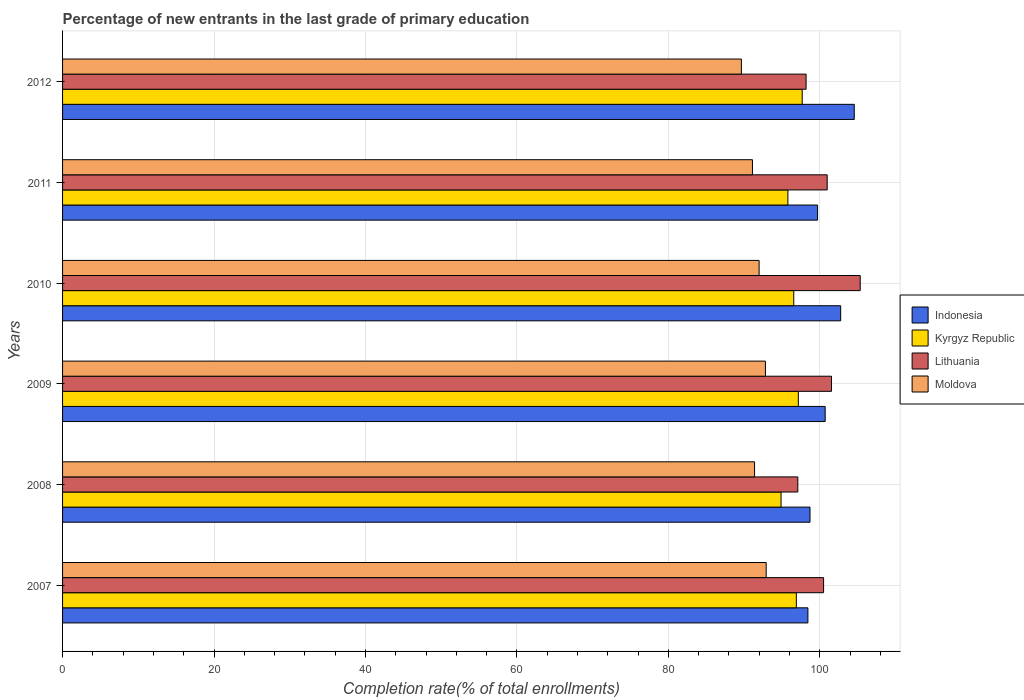Are the number of bars on each tick of the Y-axis equal?
Keep it short and to the point. Yes. How many bars are there on the 5th tick from the top?
Your answer should be very brief. 4. In how many cases, is the number of bars for a given year not equal to the number of legend labels?
Offer a very short reply. 0. What is the percentage of new entrants in Indonesia in 2010?
Offer a terse response. 102.75. Across all years, what is the maximum percentage of new entrants in Moldova?
Your answer should be very brief. 92.91. Across all years, what is the minimum percentage of new entrants in Indonesia?
Give a very brief answer. 98.42. In which year was the percentage of new entrants in Lithuania maximum?
Give a very brief answer. 2010. What is the total percentage of new entrants in Kyrgyz Republic in the graph?
Your answer should be compact. 578.94. What is the difference between the percentage of new entrants in Indonesia in 2007 and that in 2008?
Offer a very short reply. -0.28. What is the difference between the percentage of new entrants in Indonesia in 2008 and the percentage of new entrants in Moldova in 2007?
Make the answer very short. 5.79. What is the average percentage of new entrants in Lithuania per year?
Offer a terse response. 100.6. In the year 2007, what is the difference between the percentage of new entrants in Kyrgyz Republic and percentage of new entrants in Indonesia?
Provide a succinct answer. -1.53. What is the ratio of the percentage of new entrants in Kyrgyz Republic in 2007 to that in 2008?
Your answer should be compact. 1.02. Is the percentage of new entrants in Indonesia in 2009 less than that in 2011?
Make the answer very short. No. What is the difference between the highest and the second highest percentage of new entrants in Moldova?
Offer a terse response. 0.1. What is the difference between the highest and the lowest percentage of new entrants in Indonesia?
Your answer should be very brief. 6.12. In how many years, is the percentage of new entrants in Indonesia greater than the average percentage of new entrants in Indonesia taken over all years?
Ensure brevity in your answer.  2. Is it the case that in every year, the sum of the percentage of new entrants in Lithuania and percentage of new entrants in Kyrgyz Republic is greater than the sum of percentage of new entrants in Moldova and percentage of new entrants in Indonesia?
Your answer should be very brief. No. What does the 1st bar from the top in 2007 represents?
Offer a terse response. Moldova. Is it the case that in every year, the sum of the percentage of new entrants in Moldova and percentage of new entrants in Lithuania is greater than the percentage of new entrants in Kyrgyz Republic?
Give a very brief answer. Yes. How many bars are there?
Offer a very short reply. 24. What is the difference between two consecutive major ticks on the X-axis?
Your answer should be very brief. 20. Are the values on the major ticks of X-axis written in scientific E-notation?
Offer a terse response. No. Does the graph contain grids?
Give a very brief answer. Yes. Where does the legend appear in the graph?
Offer a very short reply. Center right. How are the legend labels stacked?
Give a very brief answer. Vertical. What is the title of the graph?
Provide a succinct answer. Percentage of new entrants in the last grade of primary education. Does "Togo" appear as one of the legend labels in the graph?
Provide a succinct answer. No. What is the label or title of the X-axis?
Make the answer very short. Completion rate(% of total enrollments). What is the Completion rate(% of total enrollments) of Indonesia in 2007?
Make the answer very short. 98.42. What is the Completion rate(% of total enrollments) in Kyrgyz Republic in 2007?
Make the answer very short. 96.9. What is the Completion rate(% of total enrollments) of Lithuania in 2007?
Provide a short and direct response. 100.5. What is the Completion rate(% of total enrollments) of Moldova in 2007?
Your answer should be compact. 92.91. What is the Completion rate(% of total enrollments) in Indonesia in 2008?
Make the answer very short. 98.7. What is the Completion rate(% of total enrollments) in Kyrgyz Republic in 2008?
Provide a succinct answer. 94.88. What is the Completion rate(% of total enrollments) in Lithuania in 2008?
Your answer should be compact. 97.09. What is the Completion rate(% of total enrollments) of Moldova in 2008?
Ensure brevity in your answer.  91.38. What is the Completion rate(% of total enrollments) in Indonesia in 2009?
Offer a very short reply. 100.7. What is the Completion rate(% of total enrollments) in Kyrgyz Republic in 2009?
Your answer should be very brief. 97.16. What is the Completion rate(% of total enrollments) in Lithuania in 2009?
Your answer should be very brief. 101.54. What is the Completion rate(% of total enrollments) of Moldova in 2009?
Provide a short and direct response. 92.82. What is the Completion rate(% of total enrollments) of Indonesia in 2010?
Provide a short and direct response. 102.75. What is the Completion rate(% of total enrollments) of Kyrgyz Republic in 2010?
Give a very brief answer. 96.56. What is the Completion rate(% of total enrollments) in Lithuania in 2010?
Provide a succinct answer. 105.33. What is the Completion rate(% of total enrollments) of Moldova in 2010?
Ensure brevity in your answer.  91.98. What is the Completion rate(% of total enrollments) in Indonesia in 2011?
Your response must be concise. 99.7. What is the Completion rate(% of total enrollments) of Kyrgyz Republic in 2011?
Your answer should be compact. 95.78. What is the Completion rate(% of total enrollments) in Lithuania in 2011?
Your answer should be very brief. 100.97. What is the Completion rate(% of total enrollments) of Moldova in 2011?
Make the answer very short. 91.1. What is the Completion rate(% of total enrollments) of Indonesia in 2012?
Provide a succinct answer. 104.54. What is the Completion rate(% of total enrollments) in Kyrgyz Republic in 2012?
Provide a succinct answer. 97.67. What is the Completion rate(% of total enrollments) in Lithuania in 2012?
Provide a succinct answer. 98.18. What is the Completion rate(% of total enrollments) of Moldova in 2012?
Offer a very short reply. 89.64. Across all years, what is the maximum Completion rate(% of total enrollments) of Indonesia?
Offer a very short reply. 104.54. Across all years, what is the maximum Completion rate(% of total enrollments) of Kyrgyz Republic?
Your response must be concise. 97.67. Across all years, what is the maximum Completion rate(% of total enrollments) of Lithuania?
Your response must be concise. 105.33. Across all years, what is the maximum Completion rate(% of total enrollments) of Moldova?
Provide a succinct answer. 92.91. Across all years, what is the minimum Completion rate(% of total enrollments) in Indonesia?
Make the answer very short. 98.42. Across all years, what is the minimum Completion rate(% of total enrollments) in Kyrgyz Republic?
Make the answer very short. 94.88. Across all years, what is the minimum Completion rate(% of total enrollments) of Lithuania?
Offer a very short reply. 97.09. Across all years, what is the minimum Completion rate(% of total enrollments) of Moldova?
Make the answer very short. 89.64. What is the total Completion rate(% of total enrollments) in Indonesia in the graph?
Offer a terse response. 604.82. What is the total Completion rate(% of total enrollments) in Kyrgyz Republic in the graph?
Offer a terse response. 578.94. What is the total Completion rate(% of total enrollments) in Lithuania in the graph?
Offer a terse response. 603.61. What is the total Completion rate(% of total enrollments) in Moldova in the graph?
Provide a succinct answer. 549.82. What is the difference between the Completion rate(% of total enrollments) in Indonesia in 2007 and that in 2008?
Ensure brevity in your answer.  -0.28. What is the difference between the Completion rate(% of total enrollments) of Kyrgyz Republic in 2007 and that in 2008?
Offer a terse response. 2.02. What is the difference between the Completion rate(% of total enrollments) of Lithuania in 2007 and that in 2008?
Your response must be concise. 3.4. What is the difference between the Completion rate(% of total enrollments) of Moldova in 2007 and that in 2008?
Make the answer very short. 1.54. What is the difference between the Completion rate(% of total enrollments) in Indonesia in 2007 and that in 2009?
Offer a very short reply. -2.28. What is the difference between the Completion rate(% of total enrollments) in Kyrgyz Republic in 2007 and that in 2009?
Provide a short and direct response. -0.26. What is the difference between the Completion rate(% of total enrollments) of Lithuania in 2007 and that in 2009?
Your response must be concise. -1.04. What is the difference between the Completion rate(% of total enrollments) of Moldova in 2007 and that in 2009?
Offer a very short reply. 0.1. What is the difference between the Completion rate(% of total enrollments) in Indonesia in 2007 and that in 2010?
Ensure brevity in your answer.  -4.33. What is the difference between the Completion rate(% of total enrollments) of Kyrgyz Republic in 2007 and that in 2010?
Make the answer very short. 0.34. What is the difference between the Completion rate(% of total enrollments) in Lithuania in 2007 and that in 2010?
Provide a short and direct response. -4.84. What is the difference between the Completion rate(% of total enrollments) in Moldova in 2007 and that in 2010?
Give a very brief answer. 0.93. What is the difference between the Completion rate(% of total enrollments) in Indonesia in 2007 and that in 2011?
Offer a very short reply. -1.28. What is the difference between the Completion rate(% of total enrollments) of Kyrgyz Republic in 2007 and that in 2011?
Give a very brief answer. 1.11. What is the difference between the Completion rate(% of total enrollments) in Lithuania in 2007 and that in 2011?
Make the answer very short. -0.47. What is the difference between the Completion rate(% of total enrollments) in Moldova in 2007 and that in 2011?
Offer a very short reply. 1.81. What is the difference between the Completion rate(% of total enrollments) in Indonesia in 2007 and that in 2012?
Offer a very short reply. -6.12. What is the difference between the Completion rate(% of total enrollments) in Kyrgyz Republic in 2007 and that in 2012?
Your answer should be very brief. -0.77. What is the difference between the Completion rate(% of total enrollments) in Lithuania in 2007 and that in 2012?
Make the answer very short. 2.31. What is the difference between the Completion rate(% of total enrollments) in Moldova in 2007 and that in 2012?
Make the answer very short. 3.27. What is the difference between the Completion rate(% of total enrollments) in Indonesia in 2008 and that in 2009?
Your answer should be very brief. -2. What is the difference between the Completion rate(% of total enrollments) in Kyrgyz Republic in 2008 and that in 2009?
Provide a succinct answer. -2.28. What is the difference between the Completion rate(% of total enrollments) in Lithuania in 2008 and that in 2009?
Give a very brief answer. -4.45. What is the difference between the Completion rate(% of total enrollments) in Moldova in 2008 and that in 2009?
Your answer should be compact. -1.44. What is the difference between the Completion rate(% of total enrollments) in Indonesia in 2008 and that in 2010?
Ensure brevity in your answer.  -4.05. What is the difference between the Completion rate(% of total enrollments) of Kyrgyz Republic in 2008 and that in 2010?
Offer a terse response. -1.68. What is the difference between the Completion rate(% of total enrollments) in Lithuania in 2008 and that in 2010?
Give a very brief answer. -8.24. What is the difference between the Completion rate(% of total enrollments) in Moldova in 2008 and that in 2010?
Your answer should be compact. -0.6. What is the difference between the Completion rate(% of total enrollments) of Indonesia in 2008 and that in 2011?
Ensure brevity in your answer.  -1. What is the difference between the Completion rate(% of total enrollments) in Kyrgyz Republic in 2008 and that in 2011?
Give a very brief answer. -0.9. What is the difference between the Completion rate(% of total enrollments) of Lithuania in 2008 and that in 2011?
Ensure brevity in your answer.  -3.88. What is the difference between the Completion rate(% of total enrollments) of Moldova in 2008 and that in 2011?
Make the answer very short. 0.28. What is the difference between the Completion rate(% of total enrollments) in Indonesia in 2008 and that in 2012?
Give a very brief answer. -5.84. What is the difference between the Completion rate(% of total enrollments) of Kyrgyz Republic in 2008 and that in 2012?
Give a very brief answer. -2.79. What is the difference between the Completion rate(% of total enrollments) of Lithuania in 2008 and that in 2012?
Provide a short and direct response. -1.09. What is the difference between the Completion rate(% of total enrollments) of Moldova in 2008 and that in 2012?
Ensure brevity in your answer.  1.74. What is the difference between the Completion rate(% of total enrollments) in Indonesia in 2009 and that in 2010?
Your response must be concise. -2.05. What is the difference between the Completion rate(% of total enrollments) of Kyrgyz Republic in 2009 and that in 2010?
Your answer should be compact. 0.6. What is the difference between the Completion rate(% of total enrollments) in Lithuania in 2009 and that in 2010?
Provide a succinct answer. -3.79. What is the difference between the Completion rate(% of total enrollments) in Moldova in 2009 and that in 2010?
Make the answer very short. 0.84. What is the difference between the Completion rate(% of total enrollments) in Indonesia in 2009 and that in 2011?
Offer a very short reply. 1. What is the difference between the Completion rate(% of total enrollments) of Kyrgyz Republic in 2009 and that in 2011?
Make the answer very short. 1.37. What is the difference between the Completion rate(% of total enrollments) in Lithuania in 2009 and that in 2011?
Give a very brief answer. 0.57. What is the difference between the Completion rate(% of total enrollments) in Moldova in 2009 and that in 2011?
Give a very brief answer. 1.72. What is the difference between the Completion rate(% of total enrollments) of Indonesia in 2009 and that in 2012?
Your answer should be compact. -3.84. What is the difference between the Completion rate(% of total enrollments) in Kyrgyz Republic in 2009 and that in 2012?
Keep it short and to the point. -0.51. What is the difference between the Completion rate(% of total enrollments) of Lithuania in 2009 and that in 2012?
Your answer should be very brief. 3.36. What is the difference between the Completion rate(% of total enrollments) of Moldova in 2009 and that in 2012?
Make the answer very short. 3.18. What is the difference between the Completion rate(% of total enrollments) in Indonesia in 2010 and that in 2011?
Offer a terse response. 3.05. What is the difference between the Completion rate(% of total enrollments) of Kyrgyz Republic in 2010 and that in 2011?
Your response must be concise. 0.77. What is the difference between the Completion rate(% of total enrollments) of Lithuania in 2010 and that in 2011?
Your response must be concise. 4.36. What is the difference between the Completion rate(% of total enrollments) in Moldova in 2010 and that in 2011?
Ensure brevity in your answer.  0.88. What is the difference between the Completion rate(% of total enrollments) of Indonesia in 2010 and that in 2012?
Provide a succinct answer. -1.79. What is the difference between the Completion rate(% of total enrollments) of Kyrgyz Republic in 2010 and that in 2012?
Offer a terse response. -1.11. What is the difference between the Completion rate(% of total enrollments) of Lithuania in 2010 and that in 2012?
Offer a terse response. 7.15. What is the difference between the Completion rate(% of total enrollments) of Moldova in 2010 and that in 2012?
Ensure brevity in your answer.  2.34. What is the difference between the Completion rate(% of total enrollments) of Indonesia in 2011 and that in 2012?
Provide a short and direct response. -4.84. What is the difference between the Completion rate(% of total enrollments) of Kyrgyz Republic in 2011 and that in 2012?
Offer a terse response. -1.89. What is the difference between the Completion rate(% of total enrollments) in Lithuania in 2011 and that in 2012?
Your response must be concise. 2.79. What is the difference between the Completion rate(% of total enrollments) in Moldova in 2011 and that in 2012?
Make the answer very short. 1.46. What is the difference between the Completion rate(% of total enrollments) of Indonesia in 2007 and the Completion rate(% of total enrollments) of Kyrgyz Republic in 2008?
Provide a succinct answer. 3.54. What is the difference between the Completion rate(% of total enrollments) in Indonesia in 2007 and the Completion rate(% of total enrollments) in Lithuania in 2008?
Your response must be concise. 1.33. What is the difference between the Completion rate(% of total enrollments) in Indonesia in 2007 and the Completion rate(% of total enrollments) in Moldova in 2008?
Make the answer very short. 7.05. What is the difference between the Completion rate(% of total enrollments) of Kyrgyz Republic in 2007 and the Completion rate(% of total enrollments) of Lithuania in 2008?
Provide a succinct answer. -0.19. What is the difference between the Completion rate(% of total enrollments) in Kyrgyz Republic in 2007 and the Completion rate(% of total enrollments) in Moldova in 2008?
Give a very brief answer. 5.52. What is the difference between the Completion rate(% of total enrollments) in Lithuania in 2007 and the Completion rate(% of total enrollments) in Moldova in 2008?
Your answer should be compact. 9.12. What is the difference between the Completion rate(% of total enrollments) in Indonesia in 2007 and the Completion rate(% of total enrollments) in Kyrgyz Republic in 2009?
Your response must be concise. 1.27. What is the difference between the Completion rate(% of total enrollments) of Indonesia in 2007 and the Completion rate(% of total enrollments) of Lithuania in 2009?
Provide a short and direct response. -3.12. What is the difference between the Completion rate(% of total enrollments) of Indonesia in 2007 and the Completion rate(% of total enrollments) of Moldova in 2009?
Your response must be concise. 5.61. What is the difference between the Completion rate(% of total enrollments) of Kyrgyz Republic in 2007 and the Completion rate(% of total enrollments) of Lithuania in 2009?
Make the answer very short. -4.64. What is the difference between the Completion rate(% of total enrollments) in Kyrgyz Republic in 2007 and the Completion rate(% of total enrollments) in Moldova in 2009?
Offer a terse response. 4.08. What is the difference between the Completion rate(% of total enrollments) of Lithuania in 2007 and the Completion rate(% of total enrollments) of Moldova in 2009?
Make the answer very short. 7.68. What is the difference between the Completion rate(% of total enrollments) in Indonesia in 2007 and the Completion rate(% of total enrollments) in Kyrgyz Republic in 2010?
Provide a succinct answer. 1.87. What is the difference between the Completion rate(% of total enrollments) of Indonesia in 2007 and the Completion rate(% of total enrollments) of Lithuania in 2010?
Keep it short and to the point. -6.91. What is the difference between the Completion rate(% of total enrollments) in Indonesia in 2007 and the Completion rate(% of total enrollments) in Moldova in 2010?
Keep it short and to the point. 6.44. What is the difference between the Completion rate(% of total enrollments) of Kyrgyz Republic in 2007 and the Completion rate(% of total enrollments) of Lithuania in 2010?
Offer a very short reply. -8.44. What is the difference between the Completion rate(% of total enrollments) in Kyrgyz Republic in 2007 and the Completion rate(% of total enrollments) in Moldova in 2010?
Your answer should be compact. 4.92. What is the difference between the Completion rate(% of total enrollments) of Lithuania in 2007 and the Completion rate(% of total enrollments) of Moldova in 2010?
Offer a terse response. 8.52. What is the difference between the Completion rate(% of total enrollments) of Indonesia in 2007 and the Completion rate(% of total enrollments) of Kyrgyz Republic in 2011?
Ensure brevity in your answer.  2.64. What is the difference between the Completion rate(% of total enrollments) in Indonesia in 2007 and the Completion rate(% of total enrollments) in Lithuania in 2011?
Offer a very short reply. -2.55. What is the difference between the Completion rate(% of total enrollments) in Indonesia in 2007 and the Completion rate(% of total enrollments) in Moldova in 2011?
Give a very brief answer. 7.32. What is the difference between the Completion rate(% of total enrollments) of Kyrgyz Republic in 2007 and the Completion rate(% of total enrollments) of Lithuania in 2011?
Offer a terse response. -4.07. What is the difference between the Completion rate(% of total enrollments) in Kyrgyz Republic in 2007 and the Completion rate(% of total enrollments) in Moldova in 2011?
Give a very brief answer. 5.8. What is the difference between the Completion rate(% of total enrollments) of Lithuania in 2007 and the Completion rate(% of total enrollments) of Moldova in 2011?
Give a very brief answer. 9.4. What is the difference between the Completion rate(% of total enrollments) of Indonesia in 2007 and the Completion rate(% of total enrollments) of Kyrgyz Republic in 2012?
Offer a terse response. 0.75. What is the difference between the Completion rate(% of total enrollments) of Indonesia in 2007 and the Completion rate(% of total enrollments) of Lithuania in 2012?
Offer a terse response. 0.24. What is the difference between the Completion rate(% of total enrollments) in Indonesia in 2007 and the Completion rate(% of total enrollments) in Moldova in 2012?
Give a very brief answer. 8.78. What is the difference between the Completion rate(% of total enrollments) in Kyrgyz Republic in 2007 and the Completion rate(% of total enrollments) in Lithuania in 2012?
Make the answer very short. -1.29. What is the difference between the Completion rate(% of total enrollments) in Kyrgyz Republic in 2007 and the Completion rate(% of total enrollments) in Moldova in 2012?
Ensure brevity in your answer.  7.26. What is the difference between the Completion rate(% of total enrollments) of Lithuania in 2007 and the Completion rate(% of total enrollments) of Moldova in 2012?
Give a very brief answer. 10.86. What is the difference between the Completion rate(% of total enrollments) in Indonesia in 2008 and the Completion rate(% of total enrollments) in Kyrgyz Republic in 2009?
Your answer should be compact. 1.54. What is the difference between the Completion rate(% of total enrollments) of Indonesia in 2008 and the Completion rate(% of total enrollments) of Lithuania in 2009?
Provide a short and direct response. -2.84. What is the difference between the Completion rate(% of total enrollments) in Indonesia in 2008 and the Completion rate(% of total enrollments) in Moldova in 2009?
Your answer should be very brief. 5.88. What is the difference between the Completion rate(% of total enrollments) of Kyrgyz Republic in 2008 and the Completion rate(% of total enrollments) of Lithuania in 2009?
Offer a very short reply. -6.66. What is the difference between the Completion rate(% of total enrollments) of Kyrgyz Republic in 2008 and the Completion rate(% of total enrollments) of Moldova in 2009?
Give a very brief answer. 2.06. What is the difference between the Completion rate(% of total enrollments) of Lithuania in 2008 and the Completion rate(% of total enrollments) of Moldova in 2009?
Your answer should be very brief. 4.27. What is the difference between the Completion rate(% of total enrollments) in Indonesia in 2008 and the Completion rate(% of total enrollments) in Kyrgyz Republic in 2010?
Your response must be concise. 2.14. What is the difference between the Completion rate(% of total enrollments) of Indonesia in 2008 and the Completion rate(% of total enrollments) of Lithuania in 2010?
Your response must be concise. -6.63. What is the difference between the Completion rate(% of total enrollments) of Indonesia in 2008 and the Completion rate(% of total enrollments) of Moldova in 2010?
Make the answer very short. 6.72. What is the difference between the Completion rate(% of total enrollments) in Kyrgyz Republic in 2008 and the Completion rate(% of total enrollments) in Lithuania in 2010?
Ensure brevity in your answer.  -10.45. What is the difference between the Completion rate(% of total enrollments) in Kyrgyz Republic in 2008 and the Completion rate(% of total enrollments) in Moldova in 2010?
Your answer should be very brief. 2.9. What is the difference between the Completion rate(% of total enrollments) in Lithuania in 2008 and the Completion rate(% of total enrollments) in Moldova in 2010?
Make the answer very short. 5.11. What is the difference between the Completion rate(% of total enrollments) in Indonesia in 2008 and the Completion rate(% of total enrollments) in Kyrgyz Republic in 2011?
Ensure brevity in your answer.  2.92. What is the difference between the Completion rate(% of total enrollments) in Indonesia in 2008 and the Completion rate(% of total enrollments) in Lithuania in 2011?
Provide a succinct answer. -2.27. What is the difference between the Completion rate(% of total enrollments) of Indonesia in 2008 and the Completion rate(% of total enrollments) of Moldova in 2011?
Offer a terse response. 7.6. What is the difference between the Completion rate(% of total enrollments) of Kyrgyz Republic in 2008 and the Completion rate(% of total enrollments) of Lithuania in 2011?
Provide a short and direct response. -6.09. What is the difference between the Completion rate(% of total enrollments) in Kyrgyz Republic in 2008 and the Completion rate(% of total enrollments) in Moldova in 2011?
Give a very brief answer. 3.78. What is the difference between the Completion rate(% of total enrollments) in Lithuania in 2008 and the Completion rate(% of total enrollments) in Moldova in 2011?
Provide a succinct answer. 5.99. What is the difference between the Completion rate(% of total enrollments) in Indonesia in 2008 and the Completion rate(% of total enrollments) in Kyrgyz Republic in 2012?
Ensure brevity in your answer.  1.03. What is the difference between the Completion rate(% of total enrollments) of Indonesia in 2008 and the Completion rate(% of total enrollments) of Lithuania in 2012?
Provide a succinct answer. 0.52. What is the difference between the Completion rate(% of total enrollments) of Indonesia in 2008 and the Completion rate(% of total enrollments) of Moldova in 2012?
Offer a very short reply. 9.06. What is the difference between the Completion rate(% of total enrollments) of Kyrgyz Republic in 2008 and the Completion rate(% of total enrollments) of Lithuania in 2012?
Provide a short and direct response. -3.3. What is the difference between the Completion rate(% of total enrollments) of Kyrgyz Republic in 2008 and the Completion rate(% of total enrollments) of Moldova in 2012?
Keep it short and to the point. 5.24. What is the difference between the Completion rate(% of total enrollments) of Lithuania in 2008 and the Completion rate(% of total enrollments) of Moldova in 2012?
Your answer should be very brief. 7.45. What is the difference between the Completion rate(% of total enrollments) of Indonesia in 2009 and the Completion rate(% of total enrollments) of Kyrgyz Republic in 2010?
Keep it short and to the point. 4.15. What is the difference between the Completion rate(% of total enrollments) of Indonesia in 2009 and the Completion rate(% of total enrollments) of Lithuania in 2010?
Your answer should be very brief. -4.63. What is the difference between the Completion rate(% of total enrollments) of Indonesia in 2009 and the Completion rate(% of total enrollments) of Moldova in 2010?
Give a very brief answer. 8.72. What is the difference between the Completion rate(% of total enrollments) in Kyrgyz Republic in 2009 and the Completion rate(% of total enrollments) in Lithuania in 2010?
Provide a succinct answer. -8.17. What is the difference between the Completion rate(% of total enrollments) in Kyrgyz Republic in 2009 and the Completion rate(% of total enrollments) in Moldova in 2010?
Offer a very short reply. 5.18. What is the difference between the Completion rate(% of total enrollments) of Lithuania in 2009 and the Completion rate(% of total enrollments) of Moldova in 2010?
Offer a terse response. 9.56. What is the difference between the Completion rate(% of total enrollments) of Indonesia in 2009 and the Completion rate(% of total enrollments) of Kyrgyz Republic in 2011?
Ensure brevity in your answer.  4.92. What is the difference between the Completion rate(% of total enrollments) in Indonesia in 2009 and the Completion rate(% of total enrollments) in Lithuania in 2011?
Your answer should be very brief. -0.27. What is the difference between the Completion rate(% of total enrollments) in Indonesia in 2009 and the Completion rate(% of total enrollments) in Moldova in 2011?
Offer a terse response. 9.6. What is the difference between the Completion rate(% of total enrollments) in Kyrgyz Republic in 2009 and the Completion rate(% of total enrollments) in Lithuania in 2011?
Your response must be concise. -3.81. What is the difference between the Completion rate(% of total enrollments) of Kyrgyz Republic in 2009 and the Completion rate(% of total enrollments) of Moldova in 2011?
Ensure brevity in your answer.  6.06. What is the difference between the Completion rate(% of total enrollments) of Lithuania in 2009 and the Completion rate(% of total enrollments) of Moldova in 2011?
Your answer should be very brief. 10.44. What is the difference between the Completion rate(% of total enrollments) in Indonesia in 2009 and the Completion rate(% of total enrollments) in Kyrgyz Republic in 2012?
Ensure brevity in your answer.  3.03. What is the difference between the Completion rate(% of total enrollments) in Indonesia in 2009 and the Completion rate(% of total enrollments) in Lithuania in 2012?
Your answer should be very brief. 2.52. What is the difference between the Completion rate(% of total enrollments) of Indonesia in 2009 and the Completion rate(% of total enrollments) of Moldova in 2012?
Provide a succinct answer. 11.06. What is the difference between the Completion rate(% of total enrollments) of Kyrgyz Republic in 2009 and the Completion rate(% of total enrollments) of Lithuania in 2012?
Ensure brevity in your answer.  -1.03. What is the difference between the Completion rate(% of total enrollments) in Kyrgyz Republic in 2009 and the Completion rate(% of total enrollments) in Moldova in 2012?
Ensure brevity in your answer.  7.52. What is the difference between the Completion rate(% of total enrollments) in Lithuania in 2009 and the Completion rate(% of total enrollments) in Moldova in 2012?
Your response must be concise. 11.9. What is the difference between the Completion rate(% of total enrollments) in Indonesia in 2010 and the Completion rate(% of total enrollments) in Kyrgyz Republic in 2011?
Make the answer very short. 6.97. What is the difference between the Completion rate(% of total enrollments) in Indonesia in 2010 and the Completion rate(% of total enrollments) in Lithuania in 2011?
Make the answer very short. 1.78. What is the difference between the Completion rate(% of total enrollments) in Indonesia in 2010 and the Completion rate(% of total enrollments) in Moldova in 2011?
Offer a very short reply. 11.65. What is the difference between the Completion rate(% of total enrollments) of Kyrgyz Republic in 2010 and the Completion rate(% of total enrollments) of Lithuania in 2011?
Your response must be concise. -4.41. What is the difference between the Completion rate(% of total enrollments) in Kyrgyz Republic in 2010 and the Completion rate(% of total enrollments) in Moldova in 2011?
Your answer should be very brief. 5.46. What is the difference between the Completion rate(% of total enrollments) of Lithuania in 2010 and the Completion rate(% of total enrollments) of Moldova in 2011?
Your answer should be compact. 14.23. What is the difference between the Completion rate(% of total enrollments) of Indonesia in 2010 and the Completion rate(% of total enrollments) of Kyrgyz Republic in 2012?
Provide a short and direct response. 5.08. What is the difference between the Completion rate(% of total enrollments) of Indonesia in 2010 and the Completion rate(% of total enrollments) of Lithuania in 2012?
Give a very brief answer. 4.57. What is the difference between the Completion rate(% of total enrollments) in Indonesia in 2010 and the Completion rate(% of total enrollments) in Moldova in 2012?
Offer a terse response. 13.11. What is the difference between the Completion rate(% of total enrollments) of Kyrgyz Republic in 2010 and the Completion rate(% of total enrollments) of Lithuania in 2012?
Provide a short and direct response. -1.63. What is the difference between the Completion rate(% of total enrollments) in Kyrgyz Republic in 2010 and the Completion rate(% of total enrollments) in Moldova in 2012?
Your answer should be very brief. 6.92. What is the difference between the Completion rate(% of total enrollments) in Lithuania in 2010 and the Completion rate(% of total enrollments) in Moldova in 2012?
Ensure brevity in your answer.  15.69. What is the difference between the Completion rate(% of total enrollments) of Indonesia in 2011 and the Completion rate(% of total enrollments) of Kyrgyz Republic in 2012?
Keep it short and to the point. 2.03. What is the difference between the Completion rate(% of total enrollments) of Indonesia in 2011 and the Completion rate(% of total enrollments) of Lithuania in 2012?
Offer a terse response. 1.52. What is the difference between the Completion rate(% of total enrollments) of Indonesia in 2011 and the Completion rate(% of total enrollments) of Moldova in 2012?
Your answer should be very brief. 10.06. What is the difference between the Completion rate(% of total enrollments) in Kyrgyz Republic in 2011 and the Completion rate(% of total enrollments) in Lithuania in 2012?
Ensure brevity in your answer.  -2.4. What is the difference between the Completion rate(% of total enrollments) of Kyrgyz Republic in 2011 and the Completion rate(% of total enrollments) of Moldova in 2012?
Give a very brief answer. 6.14. What is the difference between the Completion rate(% of total enrollments) of Lithuania in 2011 and the Completion rate(% of total enrollments) of Moldova in 2012?
Ensure brevity in your answer.  11.33. What is the average Completion rate(% of total enrollments) of Indonesia per year?
Your response must be concise. 100.8. What is the average Completion rate(% of total enrollments) of Kyrgyz Republic per year?
Your answer should be compact. 96.49. What is the average Completion rate(% of total enrollments) in Lithuania per year?
Ensure brevity in your answer.  100.6. What is the average Completion rate(% of total enrollments) in Moldova per year?
Your response must be concise. 91.64. In the year 2007, what is the difference between the Completion rate(% of total enrollments) in Indonesia and Completion rate(% of total enrollments) in Kyrgyz Republic?
Your answer should be very brief. 1.53. In the year 2007, what is the difference between the Completion rate(% of total enrollments) in Indonesia and Completion rate(% of total enrollments) in Lithuania?
Give a very brief answer. -2.07. In the year 2007, what is the difference between the Completion rate(% of total enrollments) of Indonesia and Completion rate(% of total enrollments) of Moldova?
Give a very brief answer. 5.51. In the year 2007, what is the difference between the Completion rate(% of total enrollments) of Kyrgyz Republic and Completion rate(% of total enrollments) of Lithuania?
Give a very brief answer. -3.6. In the year 2007, what is the difference between the Completion rate(% of total enrollments) in Kyrgyz Republic and Completion rate(% of total enrollments) in Moldova?
Ensure brevity in your answer.  3.98. In the year 2007, what is the difference between the Completion rate(% of total enrollments) of Lithuania and Completion rate(% of total enrollments) of Moldova?
Offer a terse response. 7.58. In the year 2008, what is the difference between the Completion rate(% of total enrollments) of Indonesia and Completion rate(% of total enrollments) of Kyrgyz Republic?
Your answer should be very brief. 3.82. In the year 2008, what is the difference between the Completion rate(% of total enrollments) of Indonesia and Completion rate(% of total enrollments) of Lithuania?
Give a very brief answer. 1.61. In the year 2008, what is the difference between the Completion rate(% of total enrollments) of Indonesia and Completion rate(% of total enrollments) of Moldova?
Provide a short and direct response. 7.32. In the year 2008, what is the difference between the Completion rate(% of total enrollments) of Kyrgyz Republic and Completion rate(% of total enrollments) of Lithuania?
Give a very brief answer. -2.21. In the year 2008, what is the difference between the Completion rate(% of total enrollments) of Kyrgyz Republic and Completion rate(% of total enrollments) of Moldova?
Offer a very short reply. 3.5. In the year 2008, what is the difference between the Completion rate(% of total enrollments) of Lithuania and Completion rate(% of total enrollments) of Moldova?
Provide a succinct answer. 5.71. In the year 2009, what is the difference between the Completion rate(% of total enrollments) of Indonesia and Completion rate(% of total enrollments) of Kyrgyz Republic?
Offer a terse response. 3.55. In the year 2009, what is the difference between the Completion rate(% of total enrollments) in Indonesia and Completion rate(% of total enrollments) in Lithuania?
Ensure brevity in your answer.  -0.84. In the year 2009, what is the difference between the Completion rate(% of total enrollments) of Indonesia and Completion rate(% of total enrollments) of Moldova?
Your answer should be compact. 7.89. In the year 2009, what is the difference between the Completion rate(% of total enrollments) in Kyrgyz Republic and Completion rate(% of total enrollments) in Lithuania?
Provide a short and direct response. -4.38. In the year 2009, what is the difference between the Completion rate(% of total enrollments) of Kyrgyz Republic and Completion rate(% of total enrollments) of Moldova?
Offer a terse response. 4.34. In the year 2009, what is the difference between the Completion rate(% of total enrollments) of Lithuania and Completion rate(% of total enrollments) of Moldova?
Give a very brief answer. 8.72. In the year 2010, what is the difference between the Completion rate(% of total enrollments) in Indonesia and Completion rate(% of total enrollments) in Kyrgyz Republic?
Your answer should be very brief. 6.19. In the year 2010, what is the difference between the Completion rate(% of total enrollments) in Indonesia and Completion rate(% of total enrollments) in Lithuania?
Offer a terse response. -2.58. In the year 2010, what is the difference between the Completion rate(% of total enrollments) in Indonesia and Completion rate(% of total enrollments) in Moldova?
Your answer should be very brief. 10.77. In the year 2010, what is the difference between the Completion rate(% of total enrollments) of Kyrgyz Republic and Completion rate(% of total enrollments) of Lithuania?
Make the answer very short. -8.77. In the year 2010, what is the difference between the Completion rate(% of total enrollments) in Kyrgyz Republic and Completion rate(% of total enrollments) in Moldova?
Provide a short and direct response. 4.58. In the year 2010, what is the difference between the Completion rate(% of total enrollments) in Lithuania and Completion rate(% of total enrollments) in Moldova?
Offer a terse response. 13.35. In the year 2011, what is the difference between the Completion rate(% of total enrollments) in Indonesia and Completion rate(% of total enrollments) in Kyrgyz Republic?
Offer a very short reply. 3.92. In the year 2011, what is the difference between the Completion rate(% of total enrollments) of Indonesia and Completion rate(% of total enrollments) of Lithuania?
Your answer should be compact. -1.27. In the year 2011, what is the difference between the Completion rate(% of total enrollments) of Indonesia and Completion rate(% of total enrollments) of Moldova?
Make the answer very short. 8.6. In the year 2011, what is the difference between the Completion rate(% of total enrollments) in Kyrgyz Republic and Completion rate(% of total enrollments) in Lithuania?
Keep it short and to the point. -5.19. In the year 2011, what is the difference between the Completion rate(% of total enrollments) of Kyrgyz Republic and Completion rate(% of total enrollments) of Moldova?
Offer a very short reply. 4.68. In the year 2011, what is the difference between the Completion rate(% of total enrollments) of Lithuania and Completion rate(% of total enrollments) of Moldova?
Offer a very short reply. 9.87. In the year 2012, what is the difference between the Completion rate(% of total enrollments) of Indonesia and Completion rate(% of total enrollments) of Kyrgyz Republic?
Your answer should be very brief. 6.87. In the year 2012, what is the difference between the Completion rate(% of total enrollments) of Indonesia and Completion rate(% of total enrollments) of Lithuania?
Provide a short and direct response. 6.36. In the year 2012, what is the difference between the Completion rate(% of total enrollments) of Indonesia and Completion rate(% of total enrollments) of Moldova?
Offer a terse response. 14.91. In the year 2012, what is the difference between the Completion rate(% of total enrollments) of Kyrgyz Republic and Completion rate(% of total enrollments) of Lithuania?
Keep it short and to the point. -0.51. In the year 2012, what is the difference between the Completion rate(% of total enrollments) in Kyrgyz Republic and Completion rate(% of total enrollments) in Moldova?
Your response must be concise. 8.03. In the year 2012, what is the difference between the Completion rate(% of total enrollments) in Lithuania and Completion rate(% of total enrollments) in Moldova?
Offer a terse response. 8.54. What is the ratio of the Completion rate(% of total enrollments) of Indonesia in 2007 to that in 2008?
Your response must be concise. 1. What is the ratio of the Completion rate(% of total enrollments) of Kyrgyz Republic in 2007 to that in 2008?
Offer a very short reply. 1.02. What is the ratio of the Completion rate(% of total enrollments) of Lithuania in 2007 to that in 2008?
Offer a terse response. 1.04. What is the ratio of the Completion rate(% of total enrollments) of Moldova in 2007 to that in 2008?
Keep it short and to the point. 1.02. What is the ratio of the Completion rate(% of total enrollments) of Indonesia in 2007 to that in 2009?
Your answer should be compact. 0.98. What is the ratio of the Completion rate(% of total enrollments) of Moldova in 2007 to that in 2009?
Your answer should be very brief. 1. What is the ratio of the Completion rate(% of total enrollments) of Indonesia in 2007 to that in 2010?
Offer a very short reply. 0.96. What is the ratio of the Completion rate(% of total enrollments) of Kyrgyz Republic in 2007 to that in 2010?
Provide a short and direct response. 1. What is the ratio of the Completion rate(% of total enrollments) in Lithuania in 2007 to that in 2010?
Provide a succinct answer. 0.95. What is the ratio of the Completion rate(% of total enrollments) in Moldova in 2007 to that in 2010?
Your answer should be very brief. 1.01. What is the ratio of the Completion rate(% of total enrollments) of Indonesia in 2007 to that in 2011?
Provide a short and direct response. 0.99. What is the ratio of the Completion rate(% of total enrollments) in Kyrgyz Republic in 2007 to that in 2011?
Ensure brevity in your answer.  1.01. What is the ratio of the Completion rate(% of total enrollments) of Moldova in 2007 to that in 2011?
Your answer should be compact. 1.02. What is the ratio of the Completion rate(% of total enrollments) in Indonesia in 2007 to that in 2012?
Make the answer very short. 0.94. What is the ratio of the Completion rate(% of total enrollments) in Lithuania in 2007 to that in 2012?
Your response must be concise. 1.02. What is the ratio of the Completion rate(% of total enrollments) of Moldova in 2007 to that in 2012?
Your answer should be compact. 1.04. What is the ratio of the Completion rate(% of total enrollments) of Indonesia in 2008 to that in 2009?
Ensure brevity in your answer.  0.98. What is the ratio of the Completion rate(% of total enrollments) of Kyrgyz Republic in 2008 to that in 2009?
Keep it short and to the point. 0.98. What is the ratio of the Completion rate(% of total enrollments) in Lithuania in 2008 to that in 2009?
Offer a very short reply. 0.96. What is the ratio of the Completion rate(% of total enrollments) in Moldova in 2008 to that in 2009?
Give a very brief answer. 0.98. What is the ratio of the Completion rate(% of total enrollments) in Indonesia in 2008 to that in 2010?
Offer a very short reply. 0.96. What is the ratio of the Completion rate(% of total enrollments) in Kyrgyz Republic in 2008 to that in 2010?
Offer a very short reply. 0.98. What is the ratio of the Completion rate(% of total enrollments) of Lithuania in 2008 to that in 2010?
Offer a very short reply. 0.92. What is the ratio of the Completion rate(% of total enrollments) of Kyrgyz Republic in 2008 to that in 2011?
Your answer should be very brief. 0.99. What is the ratio of the Completion rate(% of total enrollments) in Lithuania in 2008 to that in 2011?
Provide a short and direct response. 0.96. What is the ratio of the Completion rate(% of total enrollments) in Moldova in 2008 to that in 2011?
Offer a terse response. 1. What is the ratio of the Completion rate(% of total enrollments) of Indonesia in 2008 to that in 2012?
Offer a terse response. 0.94. What is the ratio of the Completion rate(% of total enrollments) in Kyrgyz Republic in 2008 to that in 2012?
Offer a very short reply. 0.97. What is the ratio of the Completion rate(% of total enrollments) in Lithuania in 2008 to that in 2012?
Your answer should be compact. 0.99. What is the ratio of the Completion rate(% of total enrollments) in Moldova in 2008 to that in 2012?
Make the answer very short. 1.02. What is the ratio of the Completion rate(% of total enrollments) in Indonesia in 2009 to that in 2010?
Offer a very short reply. 0.98. What is the ratio of the Completion rate(% of total enrollments) of Moldova in 2009 to that in 2010?
Offer a terse response. 1.01. What is the ratio of the Completion rate(% of total enrollments) in Kyrgyz Republic in 2009 to that in 2011?
Your answer should be very brief. 1.01. What is the ratio of the Completion rate(% of total enrollments) in Lithuania in 2009 to that in 2011?
Offer a very short reply. 1.01. What is the ratio of the Completion rate(% of total enrollments) of Moldova in 2009 to that in 2011?
Your response must be concise. 1.02. What is the ratio of the Completion rate(% of total enrollments) of Indonesia in 2009 to that in 2012?
Your response must be concise. 0.96. What is the ratio of the Completion rate(% of total enrollments) in Lithuania in 2009 to that in 2012?
Ensure brevity in your answer.  1.03. What is the ratio of the Completion rate(% of total enrollments) in Moldova in 2009 to that in 2012?
Make the answer very short. 1.04. What is the ratio of the Completion rate(% of total enrollments) in Indonesia in 2010 to that in 2011?
Your answer should be compact. 1.03. What is the ratio of the Completion rate(% of total enrollments) in Lithuania in 2010 to that in 2011?
Ensure brevity in your answer.  1.04. What is the ratio of the Completion rate(% of total enrollments) of Moldova in 2010 to that in 2011?
Your answer should be very brief. 1.01. What is the ratio of the Completion rate(% of total enrollments) in Indonesia in 2010 to that in 2012?
Make the answer very short. 0.98. What is the ratio of the Completion rate(% of total enrollments) in Lithuania in 2010 to that in 2012?
Your response must be concise. 1.07. What is the ratio of the Completion rate(% of total enrollments) in Moldova in 2010 to that in 2012?
Give a very brief answer. 1.03. What is the ratio of the Completion rate(% of total enrollments) of Indonesia in 2011 to that in 2012?
Your answer should be very brief. 0.95. What is the ratio of the Completion rate(% of total enrollments) in Kyrgyz Republic in 2011 to that in 2012?
Keep it short and to the point. 0.98. What is the ratio of the Completion rate(% of total enrollments) in Lithuania in 2011 to that in 2012?
Provide a short and direct response. 1.03. What is the ratio of the Completion rate(% of total enrollments) of Moldova in 2011 to that in 2012?
Ensure brevity in your answer.  1.02. What is the difference between the highest and the second highest Completion rate(% of total enrollments) of Indonesia?
Your response must be concise. 1.79. What is the difference between the highest and the second highest Completion rate(% of total enrollments) of Kyrgyz Republic?
Offer a very short reply. 0.51. What is the difference between the highest and the second highest Completion rate(% of total enrollments) in Lithuania?
Offer a terse response. 3.79. What is the difference between the highest and the second highest Completion rate(% of total enrollments) in Moldova?
Provide a short and direct response. 0.1. What is the difference between the highest and the lowest Completion rate(% of total enrollments) in Indonesia?
Offer a terse response. 6.12. What is the difference between the highest and the lowest Completion rate(% of total enrollments) in Kyrgyz Republic?
Your response must be concise. 2.79. What is the difference between the highest and the lowest Completion rate(% of total enrollments) of Lithuania?
Ensure brevity in your answer.  8.24. What is the difference between the highest and the lowest Completion rate(% of total enrollments) of Moldova?
Provide a succinct answer. 3.27. 